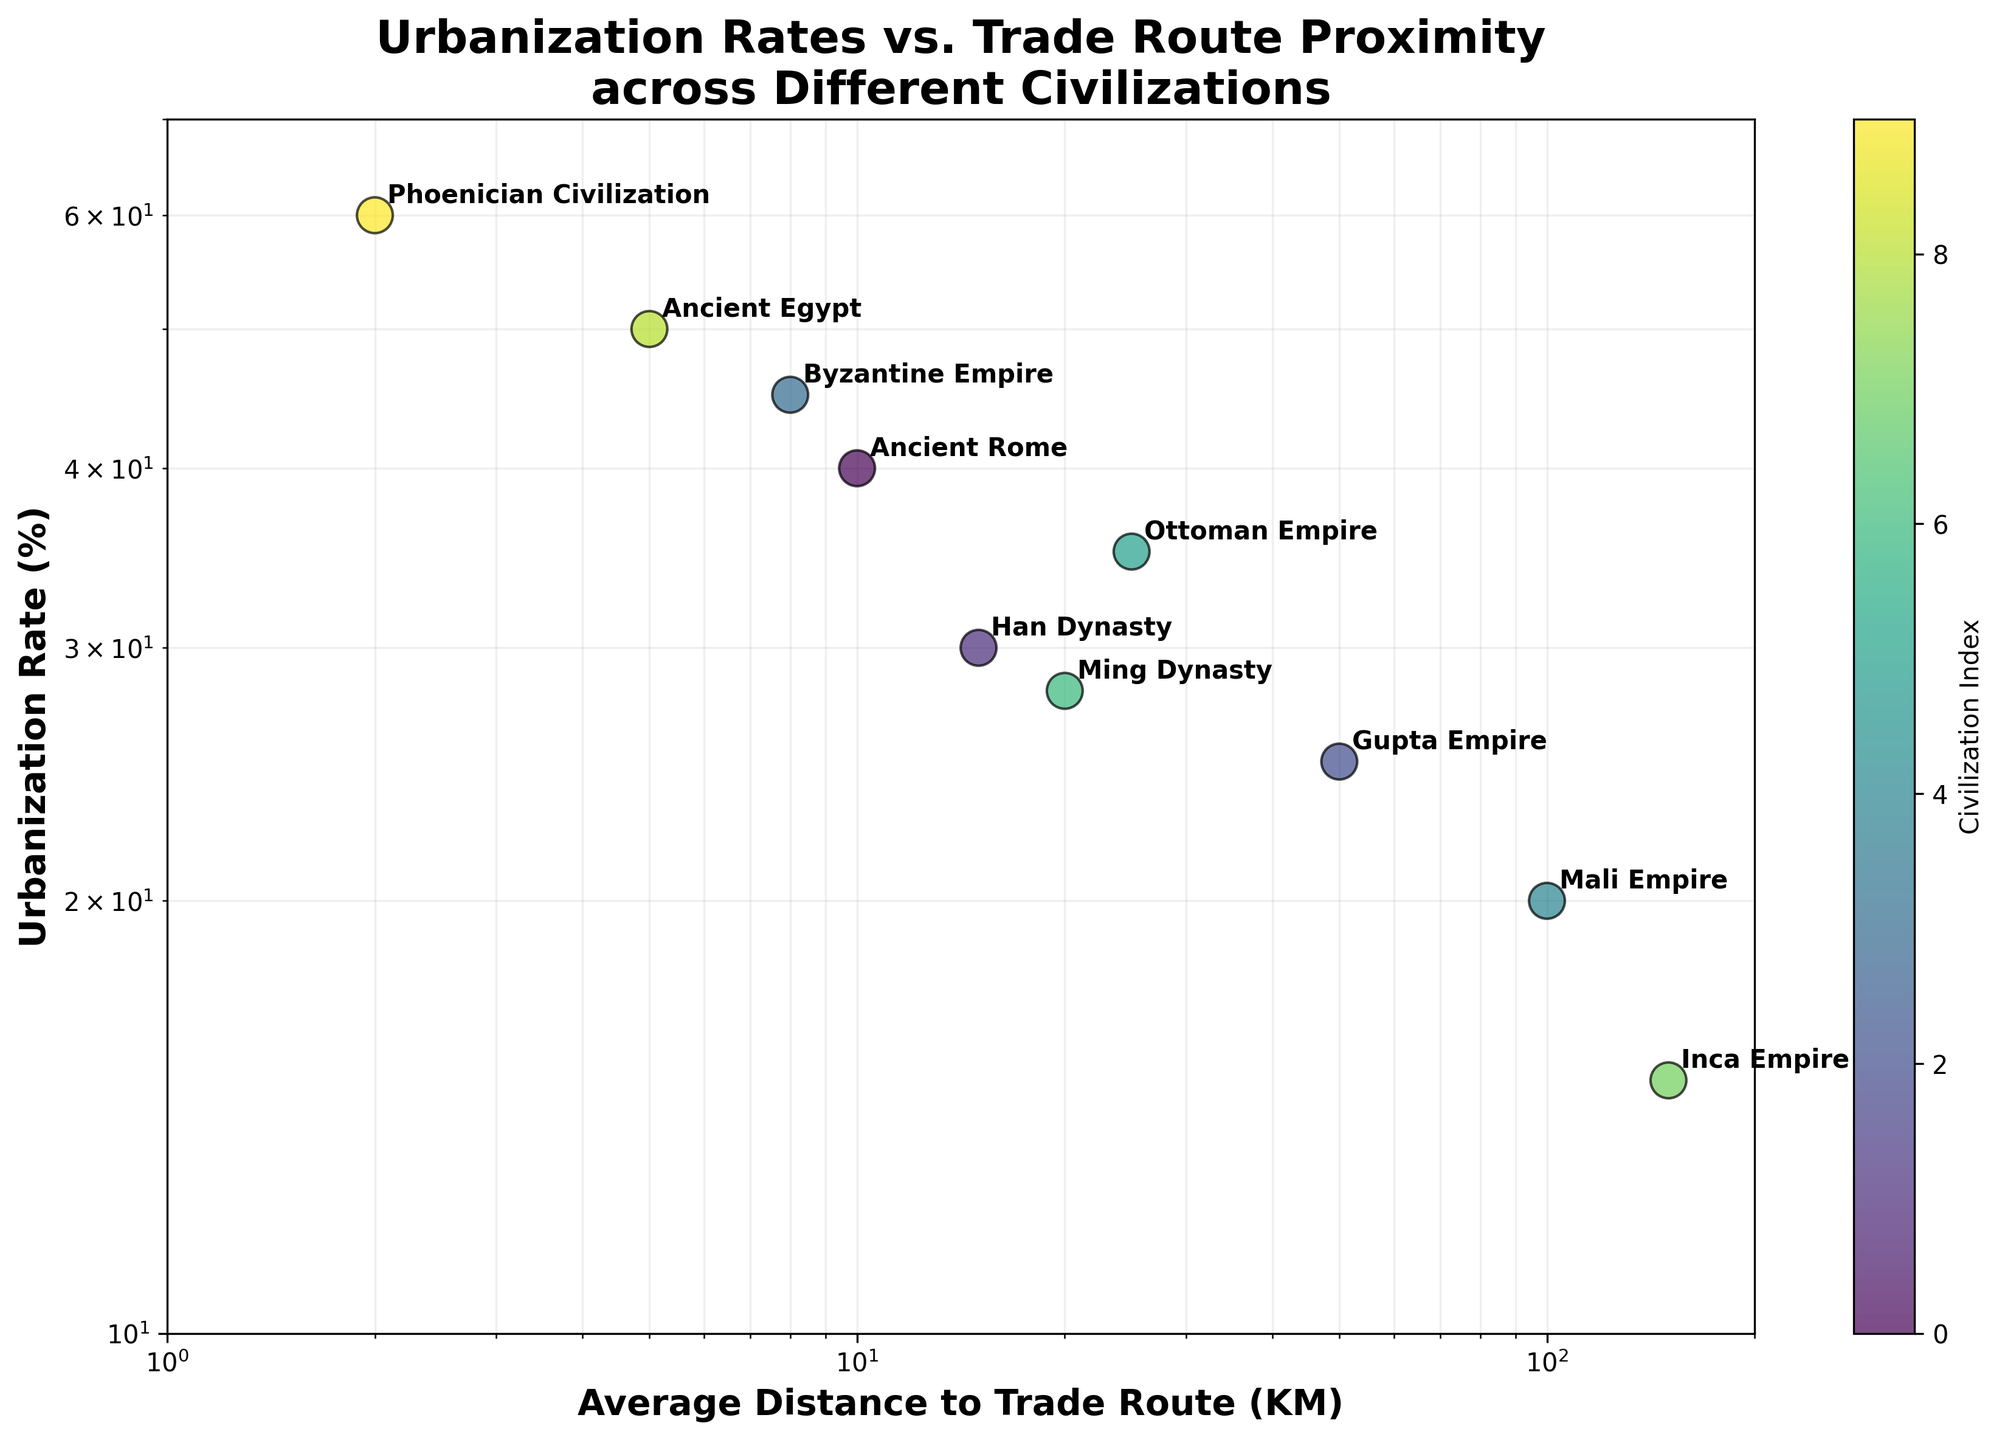What's the title of the figure? The title is prominently displayed at the top of the figure. It reads 'Urbanization Rates vs. Trade Route Proximity across Different Civilizations'. This provides a quick overview of what the plot represents.
Answer: Urbanization Rates vs. Trade Route Proximity across Different Civilizations How many civilizations are represented in the figure? By counting the unique annotations, it is clear that there are 10 civilizations represented in the figure. Each point in the scatter plot is labeled with the name of a civilization.
Answer: 10 Which civilization has the highest urbanization rate and what is it? The civilization with the highest urbanization rate is indicated by the position on the y-axis. The Phoenician Civilization has the highest value at 60%.
Answer: Phoenician Civilization, 60% What's the range for the average distance to trade routes represented on the x-axis? The x-axis range can be determined by the plotted points and the axis labels; it stretches from 1 KM to 200 KM.
Answer: 1 to 200 KM Which civilization has the shortest average distance to trade routes, and what is its urbanization rate? By looking at the leftmost point on the x-axis, we identify the Phoenician Civilization at 2 KM. Its urbanization rate is labeled as 60%.
Answer: Phoenician Civilization, 60% Comparing the Han Dynasty and the Ming Dynasty, which has a higher urbanization rate, and by how much? Locate both on the scatter plot and compare their positions on the y-axis. Han Dynasty's rate is 30%, and Ming Dynasty's rate is 28%, giving a difference of 2%.
Answer: Han Dynasty, 2% Which civilization is closest to the trade routes but has a lower urbanization rate compared to Ancient Rome? Ancient Rome is at 10 KM, 40%. The Byzantine Empire is at 8 KM but surpasses Ancient Rome with 45%, so it doesn't qualify. The best match is the Han Dynasty at 15 KM and 30%.
Answer: Han Dynasty Is there a noticeable correlation between distance to trade routes and urbanization rate? By observing the trend in the data points' positions on the scatter plot, we can ascertain a general inverse relationship, where closer proximity to trade routes tends to align with higher urbanization rates.
Answer: Yes Which civilization is furthest from trade routes and what is its urbanization rate? The furthest point along the x-axis is the Inca Empire positioned at 150 KM. Its corresponding urbanization rate is 15%.
Answer: Inca Empire, 15% What civilization has the lowest urbanization rate, and what is its average distance to trade routes? The lowest urbanization rate is identified by the bottom-most point on the y-axis. The Inca Empire has the lowest rate at 15% and its distance to trade routes is 150 KM.
Answer: Inca Empire, 150 KM 